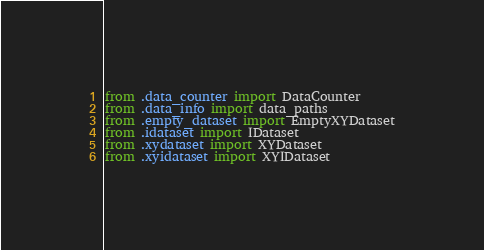Convert code to text. <code><loc_0><loc_0><loc_500><loc_500><_Python_>from .data_counter import DataCounter
from .data_info import data_paths
from .empty_dataset import EmptyXYDataset
from .idataset import IDataset
from .xydataset import XYDataset
from .xyidataset import XYIDataset
</code> 